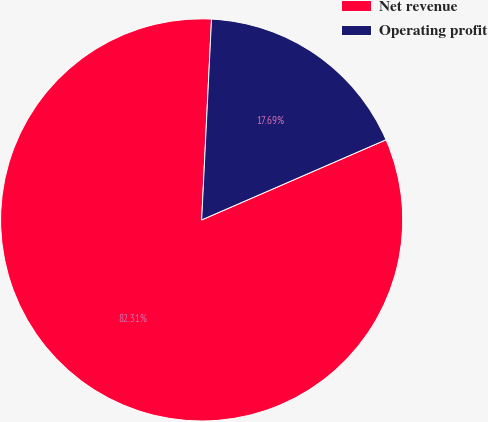Convert chart to OTSL. <chart><loc_0><loc_0><loc_500><loc_500><pie_chart><fcel>Net revenue<fcel>Operating profit<nl><fcel>82.31%<fcel>17.69%<nl></chart> 